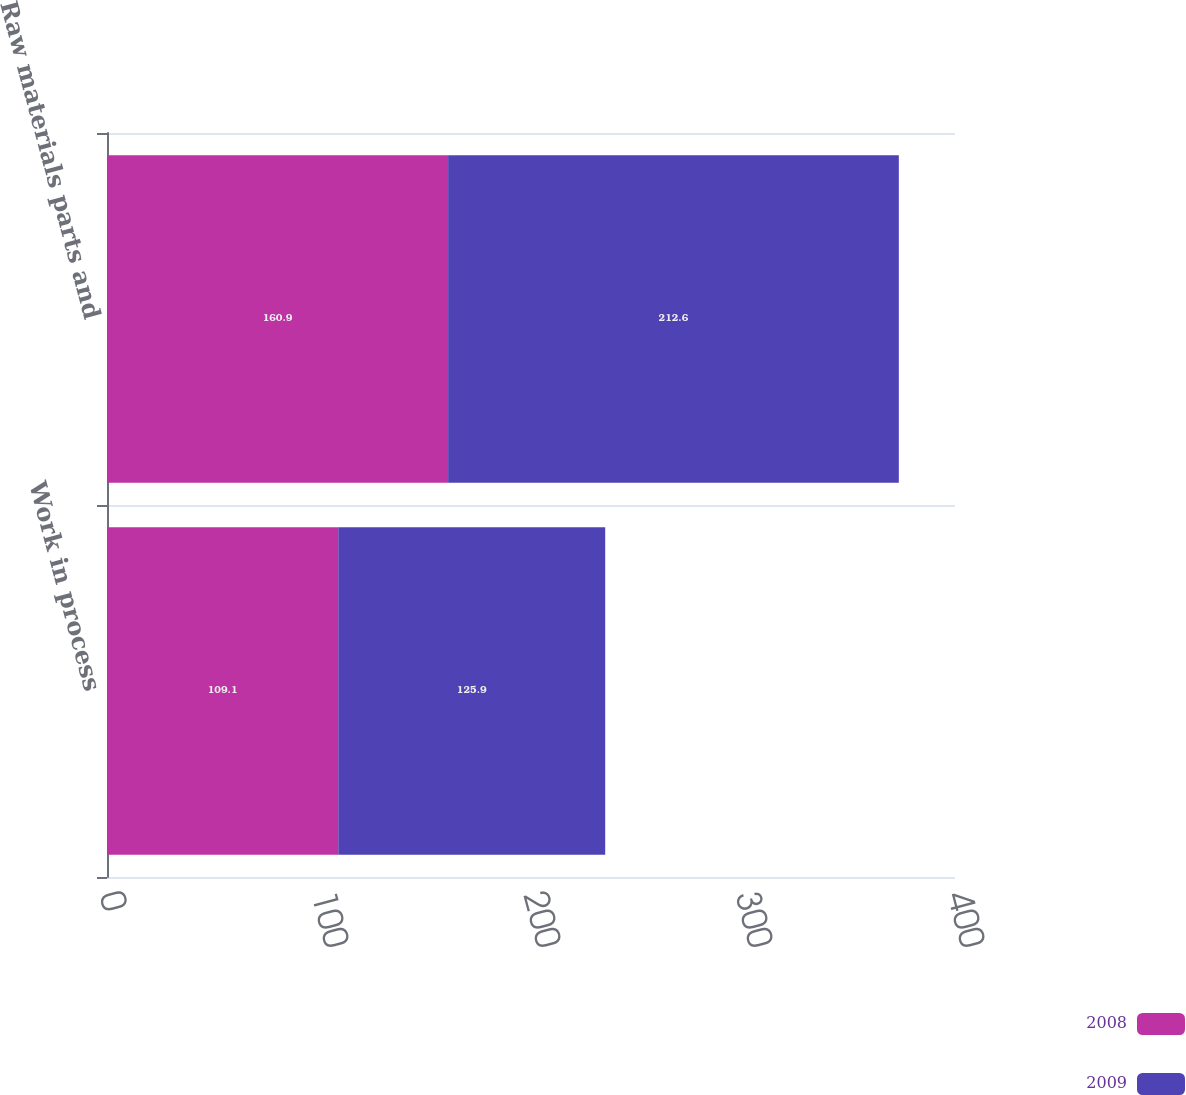Convert chart. <chart><loc_0><loc_0><loc_500><loc_500><stacked_bar_chart><ecel><fcel>Work in process<fcel>Raw materials parts and<nl><fcel>2008<fcel>109.1<fcel>160.9<nl><fcel>2009<fcel>125.9<fcel>212.6<nl></chart> 